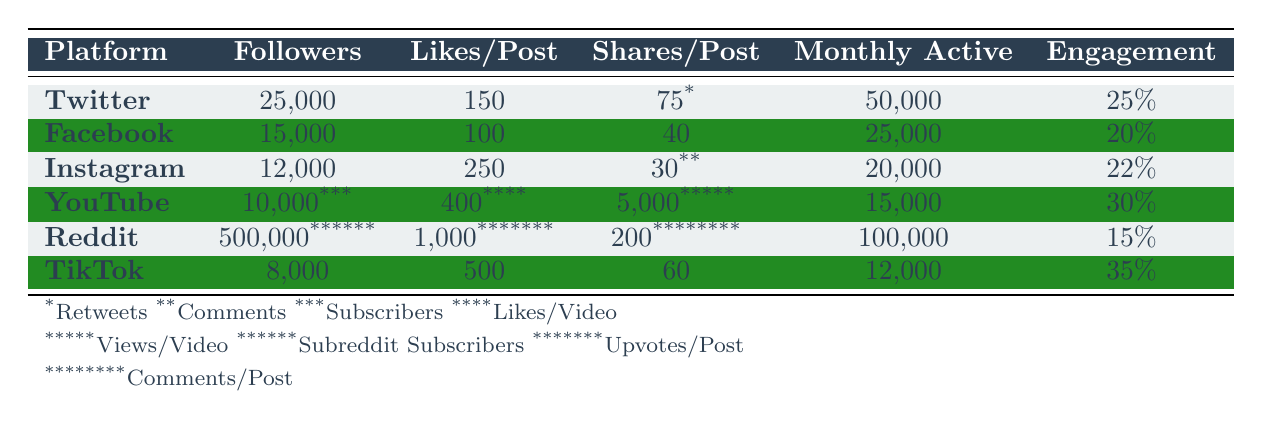What is the engagement rate for TikTok? From the table, under the TikTok row, the engagement rate is clearly indicated as 35%.
Answer: 35% Which platform has the highest number of followers? By comparing the followers across all platforms listed in the table, Reddit has the highest number with 500,000 followers.
Answer: 500,000 How many monthly active users does YouTube have? Looking at the YouTube row in the table, the number of monthly active users is listed as 15,000.
Answer: 15,000 What is the average engagement rate for all platforms listed? To find the average engagement rate, I will add the engagement rates of all platforms: 0.25 (Twitter) + 0.20 (Facebook) + 0.22 (Instagram) + 0.30 (YouTube) + 0.15 (Reddit) + 0.35 (TikTok) = 1.47. There are 6 platforms, so 1.47 divided by 6 equals approximately 0.245, or 24.5%.
Answer: 24.5% Does Instagram have more likes per post than Facebook? From the table, Instagram has 250 likes per post and Facebook has 100 likes per post. Since 250 is greater than 100, the answer is yes.
Answer: Yes Which platform has the least number of monthly active users? Comparing the numbers of monthly active users from the table, TikTok has the least with 12,000 monthly active users.
Answer: 12,000 Is the average likes per post across the platforms greater than or equal to 200? The likes per post are as follows: 150 (Twitter), 100 (Facebook), 250 (Instagram), 400 (YouTube), 1,000 (Reddit), and 500 (TikTok). Adding these together gives a total of 2,400. There are 6 platforms; so, the average likes per post is 2,400 divided by 6, which equals 400. Since 400 is greater than 200, the answer is yes.
Answer: Yes If you combine the monthly active users of Twitter, Facebook, and Instagram, what will that total be? The monthly active users for Twitter are 50,000, for Facebook are 25,000, and for Instagram are 20,000. Adding these together: 50,000 + 25,000 + 20,000 = 95,000 monthly active users total.
Answer: 95,000 